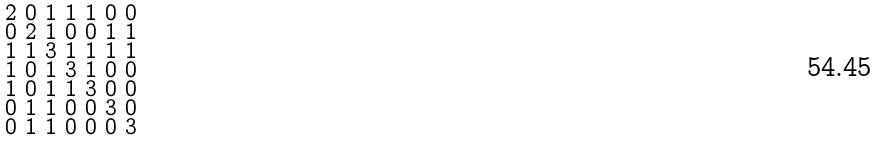<formula> <loc_0><loc_0><loc_500><loc_500>\begin{smallmatrix} 2 & 0 & 1 & 1 & 1 & 0 & 0 \\ 0 & 2 & 1 & 0 & 0 & 1 & 1 \\ 1 & 1 & 3 & 1 & 1 & 1 & 1 \\ 1 & 0 & 1 & 3 & 1 & 0 & 0 \\ 1 & 0 & 1 & 1 & 3 & 0 & 0 \\ 0 & 1 & 1 & 0 & 0 & 3 & 0 \\ 0 & 1 & 1 & 0 & 0 & 0 & 3 \end{smallmatrix}</formula> 